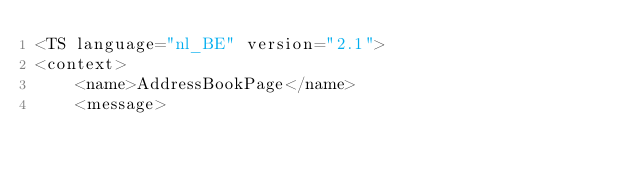Convert code to text. <code><loc_0><loc_0><loc_500><loc_500><_TypeScript_><TS language="nl_BE" version="2.1">
<context>
    <name>AddressBookPage</name>
    <message></code> 